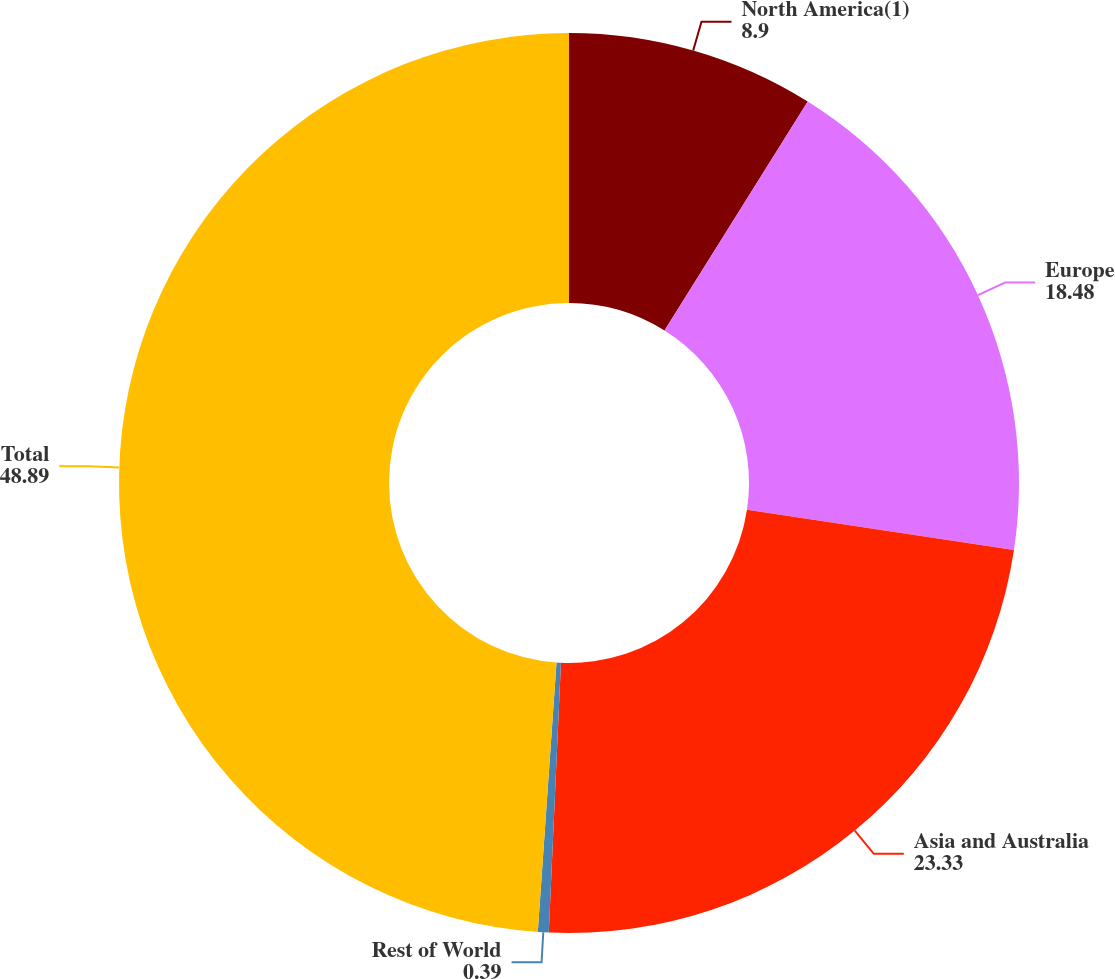Convert chart. <chart><loc_0><loc_0><loc_500><loc_500><pie_chart><fcel>North America(1)<fcel>Europe<fcel>Asia and Australia<fcel>Rest of World<fcel>Total<nl><fcel>8.9%<fcel>18.48%<fcel>23.33%<fcel>0.39%<fcel>48.89%<nl></chart> 